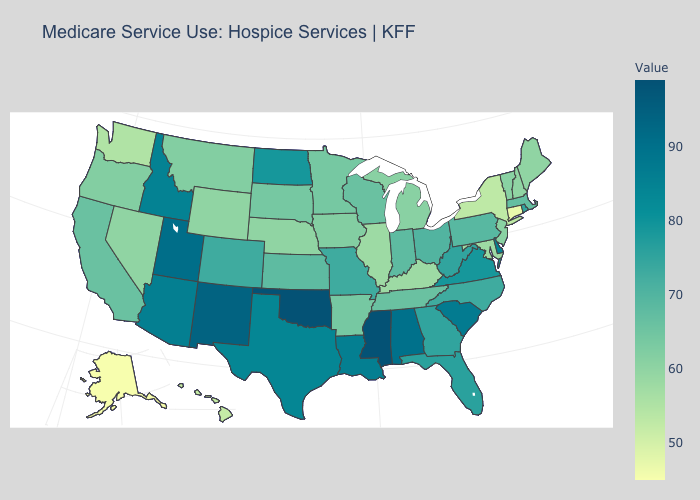Is the legend a continuous bar?
Write a very short answer. Yes. Does Missouri have a lower value than Michigan?
Short answer required. No. Does Nebraska have a lower value than Louisiana?
Be succinct. Yes. Which states have the lowest value in the USA?
Answer briefly. Alaska. 